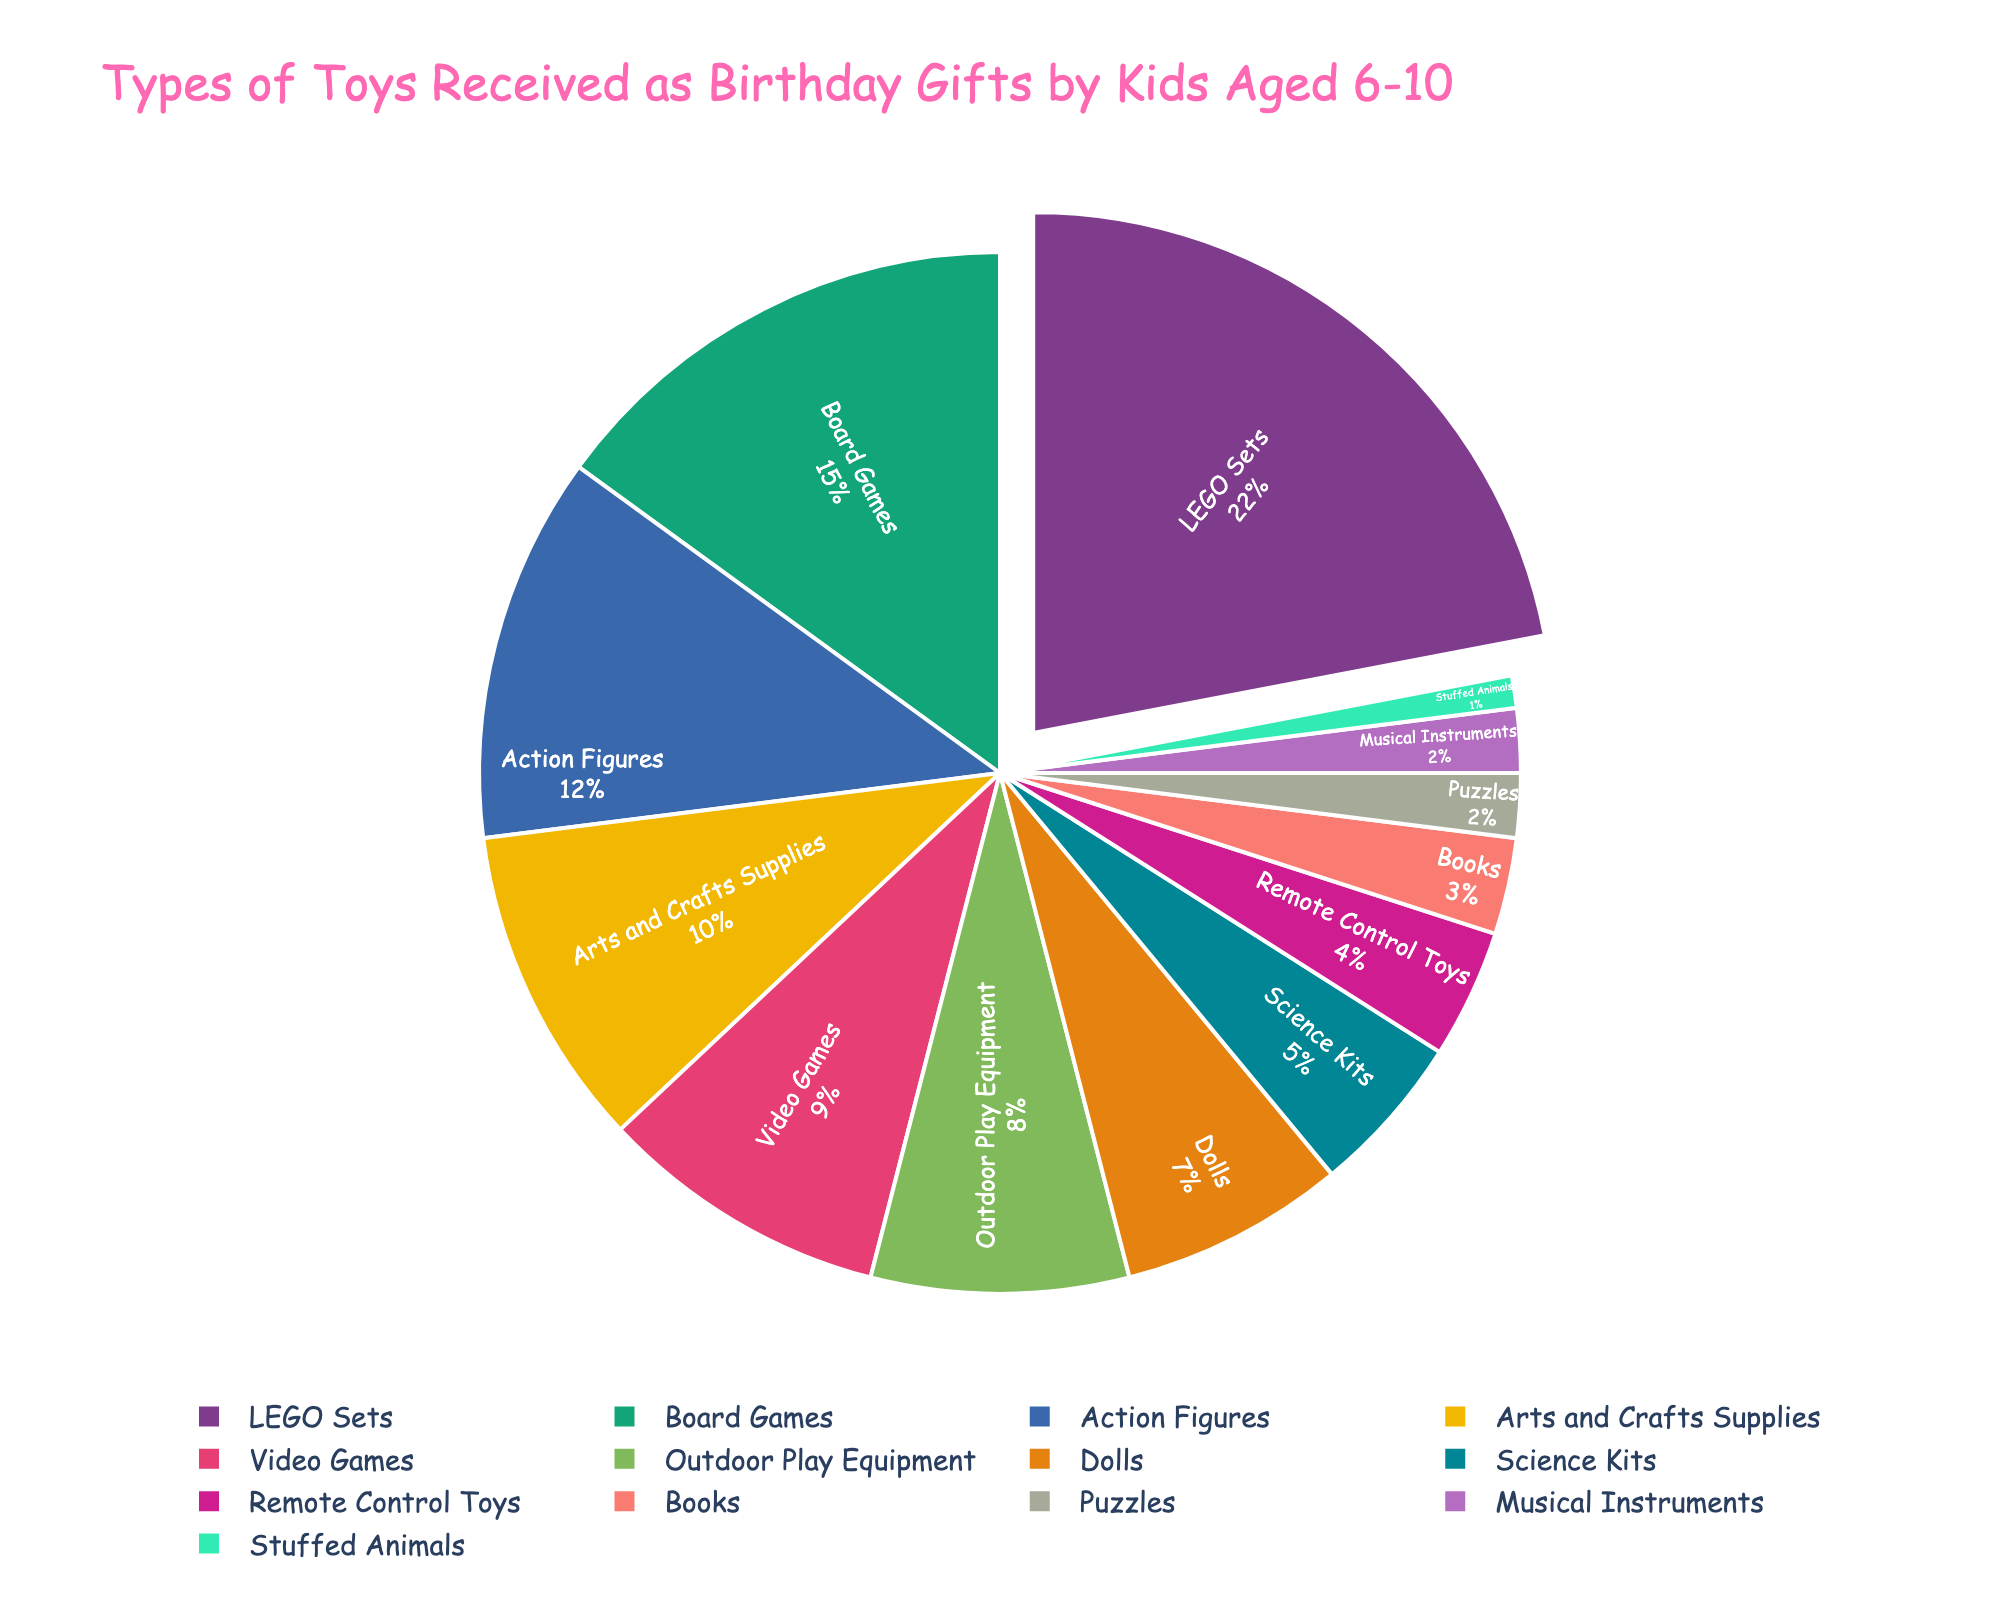What's the most popular type of toy received as birthday gifts by kids aged 6-10? The pie chart shows the largest segment labeled with 22%, which corresponds to LEGO Sets.
Answer: LEGO Sets Which type of toy is less popular: Dolls or Action Figures? By comparing the segments, Dolls have a smaller slice labeled 7%, while Action Figures have a larger slice labeled 12%.
Answer: Dolls What percentage of the total do Arts and Crafts Supplies and Science Kits make up together? The pie chart shows Arts and Crafts Supplies at 10% and Science Kits at 5%. Adding these two percentages together, 10% + 5% equals 15%.
Answer: 15% Do video games or stuffed animals make up a larger percentage of birthday gifts? From the pie chart, Video Games account for 9%, while Stuffed Animals account for only 1%. Thus, Video Games have a larger percentage.
Answer: Video Games How much more popular are Board Games compared to Puzzles? The pie chart indicates that Board Games are 15% and Puzzles are 2%. Subtracting the smaller percentage from the larger, 15% - 2% = 13%.
Answer: 13% Which category has the smallest slice in the pie chart? The smallest segment in the pie chart corresponds to Stuffed Animals, with a percentage of 1%.
Answer: Stuffed Animals What is the total percentage of toys related to creative activities (Arts and Crafts Supplies, Science Kits, Musical Instruments)? The pie chart shows Arts and Crafts Supplies as 10%, Science Kits as 5%, and Musical Instruments as 2%. Adding these values together: 10% + 5% + 2% = 17%.
Answer: 17% Among Outdoor Play Equipment and Remote Control Toys, which is less common? The pie chart shows Outdoor Play Equipment at 8% and Remote Control Toys at 4%. Thus, Remote Control Toys are less common.
Answer: Remote Control Toys How does the percentage of Books compare to that of Dolls? The pie chart shows Books at 3% and Dolls at 7%. Comparing these two values, 3% is less than 7%.
Answer: Books What percentage of the gifts are educational (Science Kits, Books)? The pie chart lists Science Kits as 5% and Books as 3%. Adding these amounts gives 5% + 3% = 8%.
Answer: 8% 